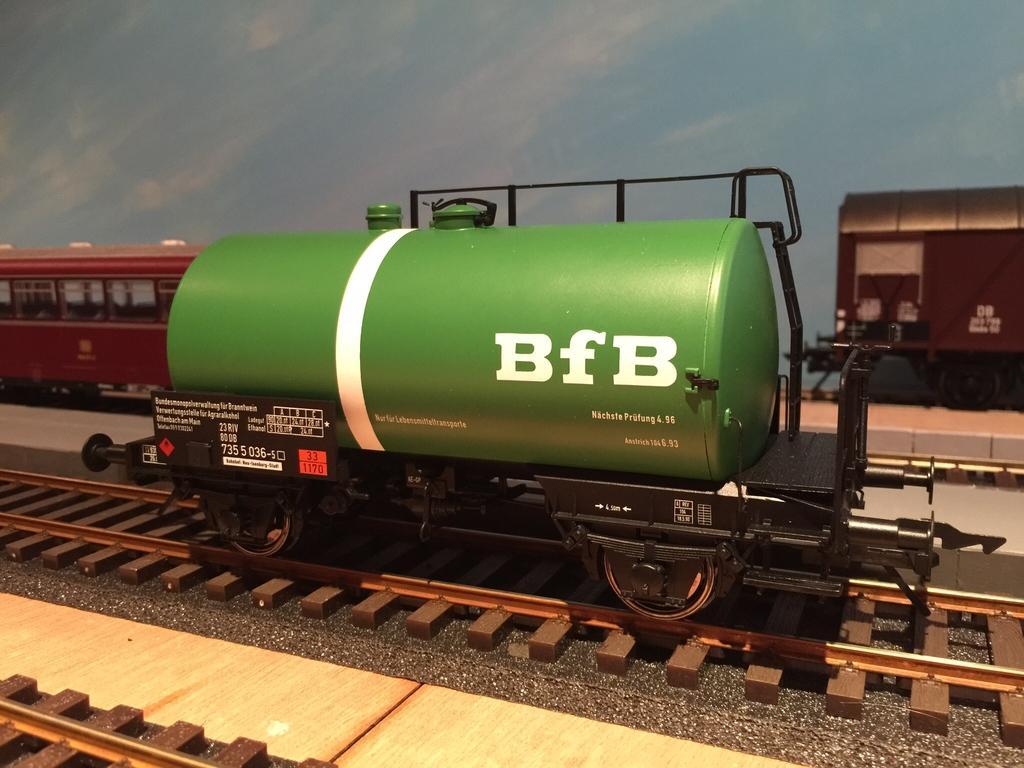Describe this image in one or two sentences. In this picture I can see scale model trains on the tracks, and there is blue background. 